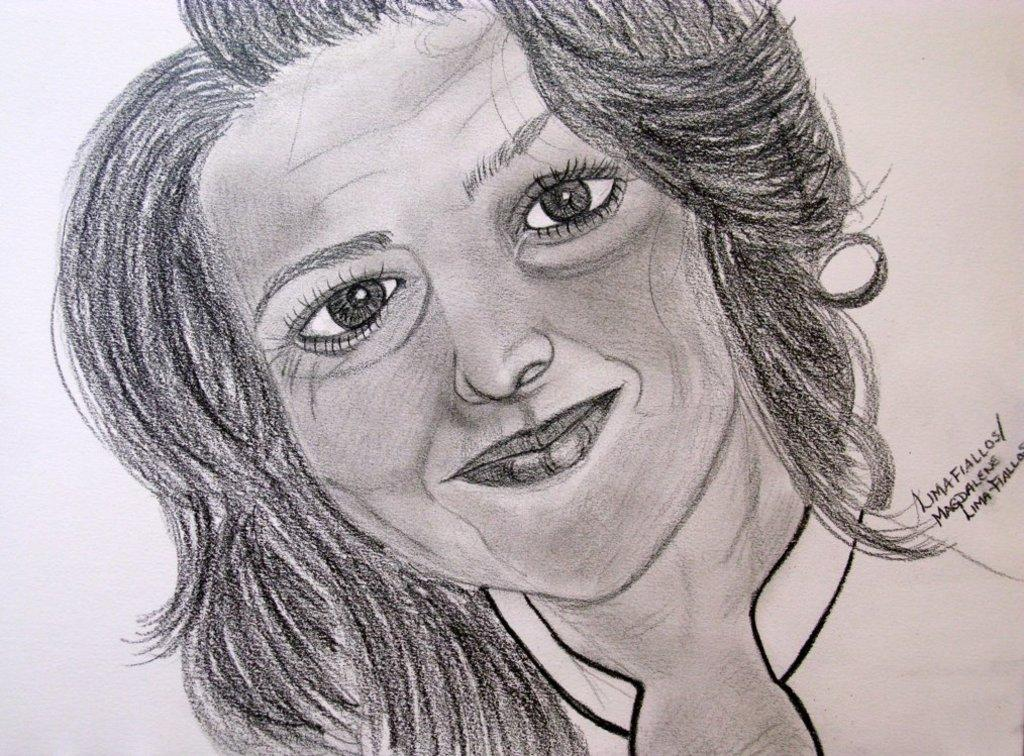What is the main subject of the image? The main subject of the image is a drawing of a girl. Is there any text present in the image? Yes, there is text at the right side of the image. What type of fireman is depicted in the image? There is no fireman present in the image; it features a drawing of a girl and text. How many bricks are visible in the image? There are no bricks visible in the image. 